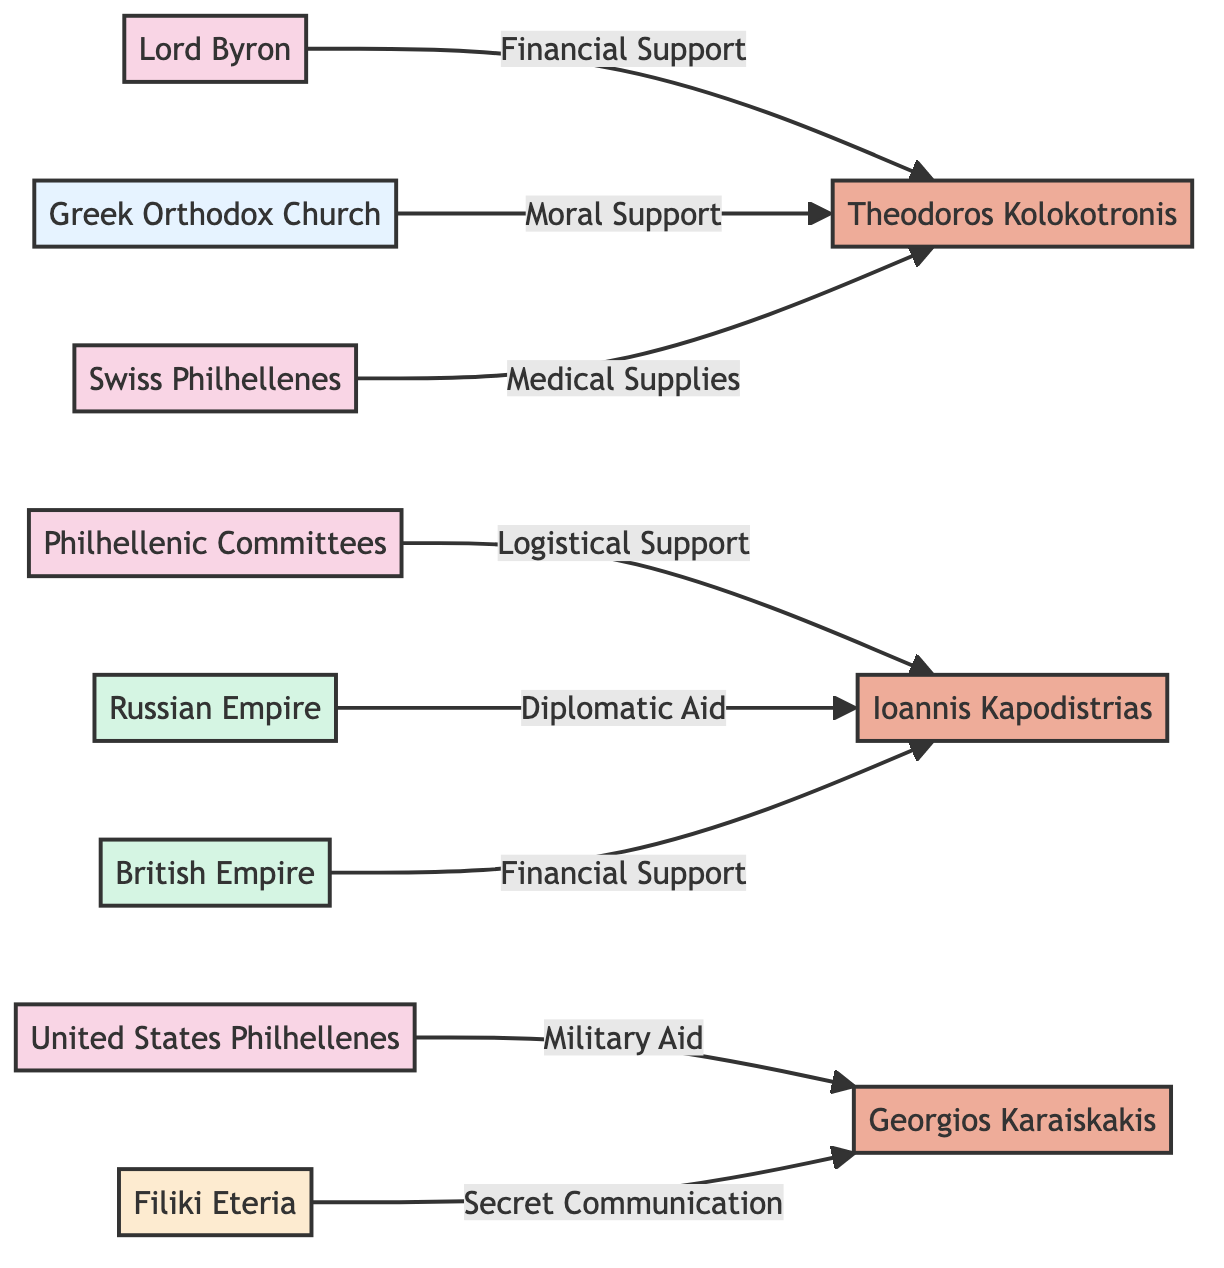What is the total number of nodes in the diagram? The diagram contains 11 nodes as listed under the "nodes" section of the provided data, which include foreign supporters, local heroes, a resource provider, foreign aid sources, and a secret society.
Answer: 11 Which local hero received financial support from Lord Byron? By inspecting the link connections in the diagram, we notice that there is a direct connection from Lord Byron (node 1) to Theodoros Kolokotronis (node 5) marked with "Financial Support".
Answer: Theodoros Kolokotronis How many types of foreign supporters are shown in the diagram? The diagram indicates three unique foreign supporter nodes: Lord Byron, Philhellenic Committees, and United States Philhellenes. Counting these gives a total of three types of foreign supporters.
Answer: 3 Who provided diplomatic aid to Ioannis Kapodistrias? By tracing the links originating from the foreign aid sources to the local heroes, we find that the Russian Empire (node 8) is linked to Ioannis Kapodistrias (node 4) with a connection labeled "Diplomatic Aid".
Answer: Russian Empire What type of support did the Greek Orthodox Church provide to Theodoros Kolokotronis? The connection from the Greek Orthodox Church (node 7) to Theodoros Kolokotronis (node 5) indicates that it provided "Moral Support".
Answer: Moral Support Which local hero received medical supplies, and who provided them? Examining the links, we see that medical supplies were provided by Swiss Philhellenes (node 11) to Theodoros Kolokotronis (node 5). The relationship is explicitly labeled as "Medical Supplies".
Answer: Theodoros Kolokotronis; Swiss Philhellenes How many types of resources are supplied by foreign sources in the diagram? The diagram includes two types of resources: foreign aid and foreign supporters. The foreign aid shows links to local heroes through different types of support such as financial and diplomatic aid.
Answer: 2 From which foreign supporter did Georgios Karaiskakis receive military aid? By checking the relationships, the link between United States Philhellenes (node 3) and Georgios Karaiskakis (node 6) is explicitly mentioned with "Military Aid".
Answer: United States Philhellenes Which node acts as a secret society in the diagram? The node labeled "Filiki Eteria" (node 10) is clearly identified as the secret society in the diagram. This information can be confirmed by looking at the node types specified.
Answer: Filiki Eteria 